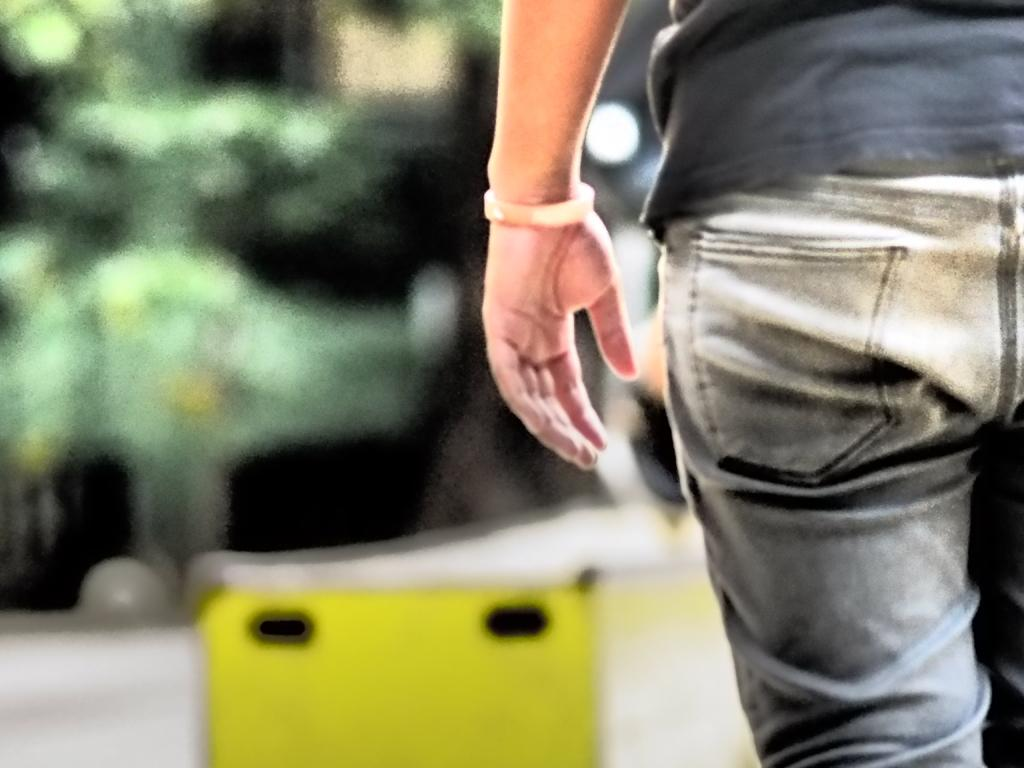What is the main subject of the image? There is a man in the image. What is the man wearing? The man is wearing a black t-shirt. What can be seen in the background of the image? There are buildings and trees in the background of the image. How would you describe the background of the image? The background is slightly blurred. What type of writing can be seen on the man's t-shirt in the image? There is no writing visible on the man's t-shirt in the image. How many oranges are visible on the man's head in the image? There are no oranges present in the image. 